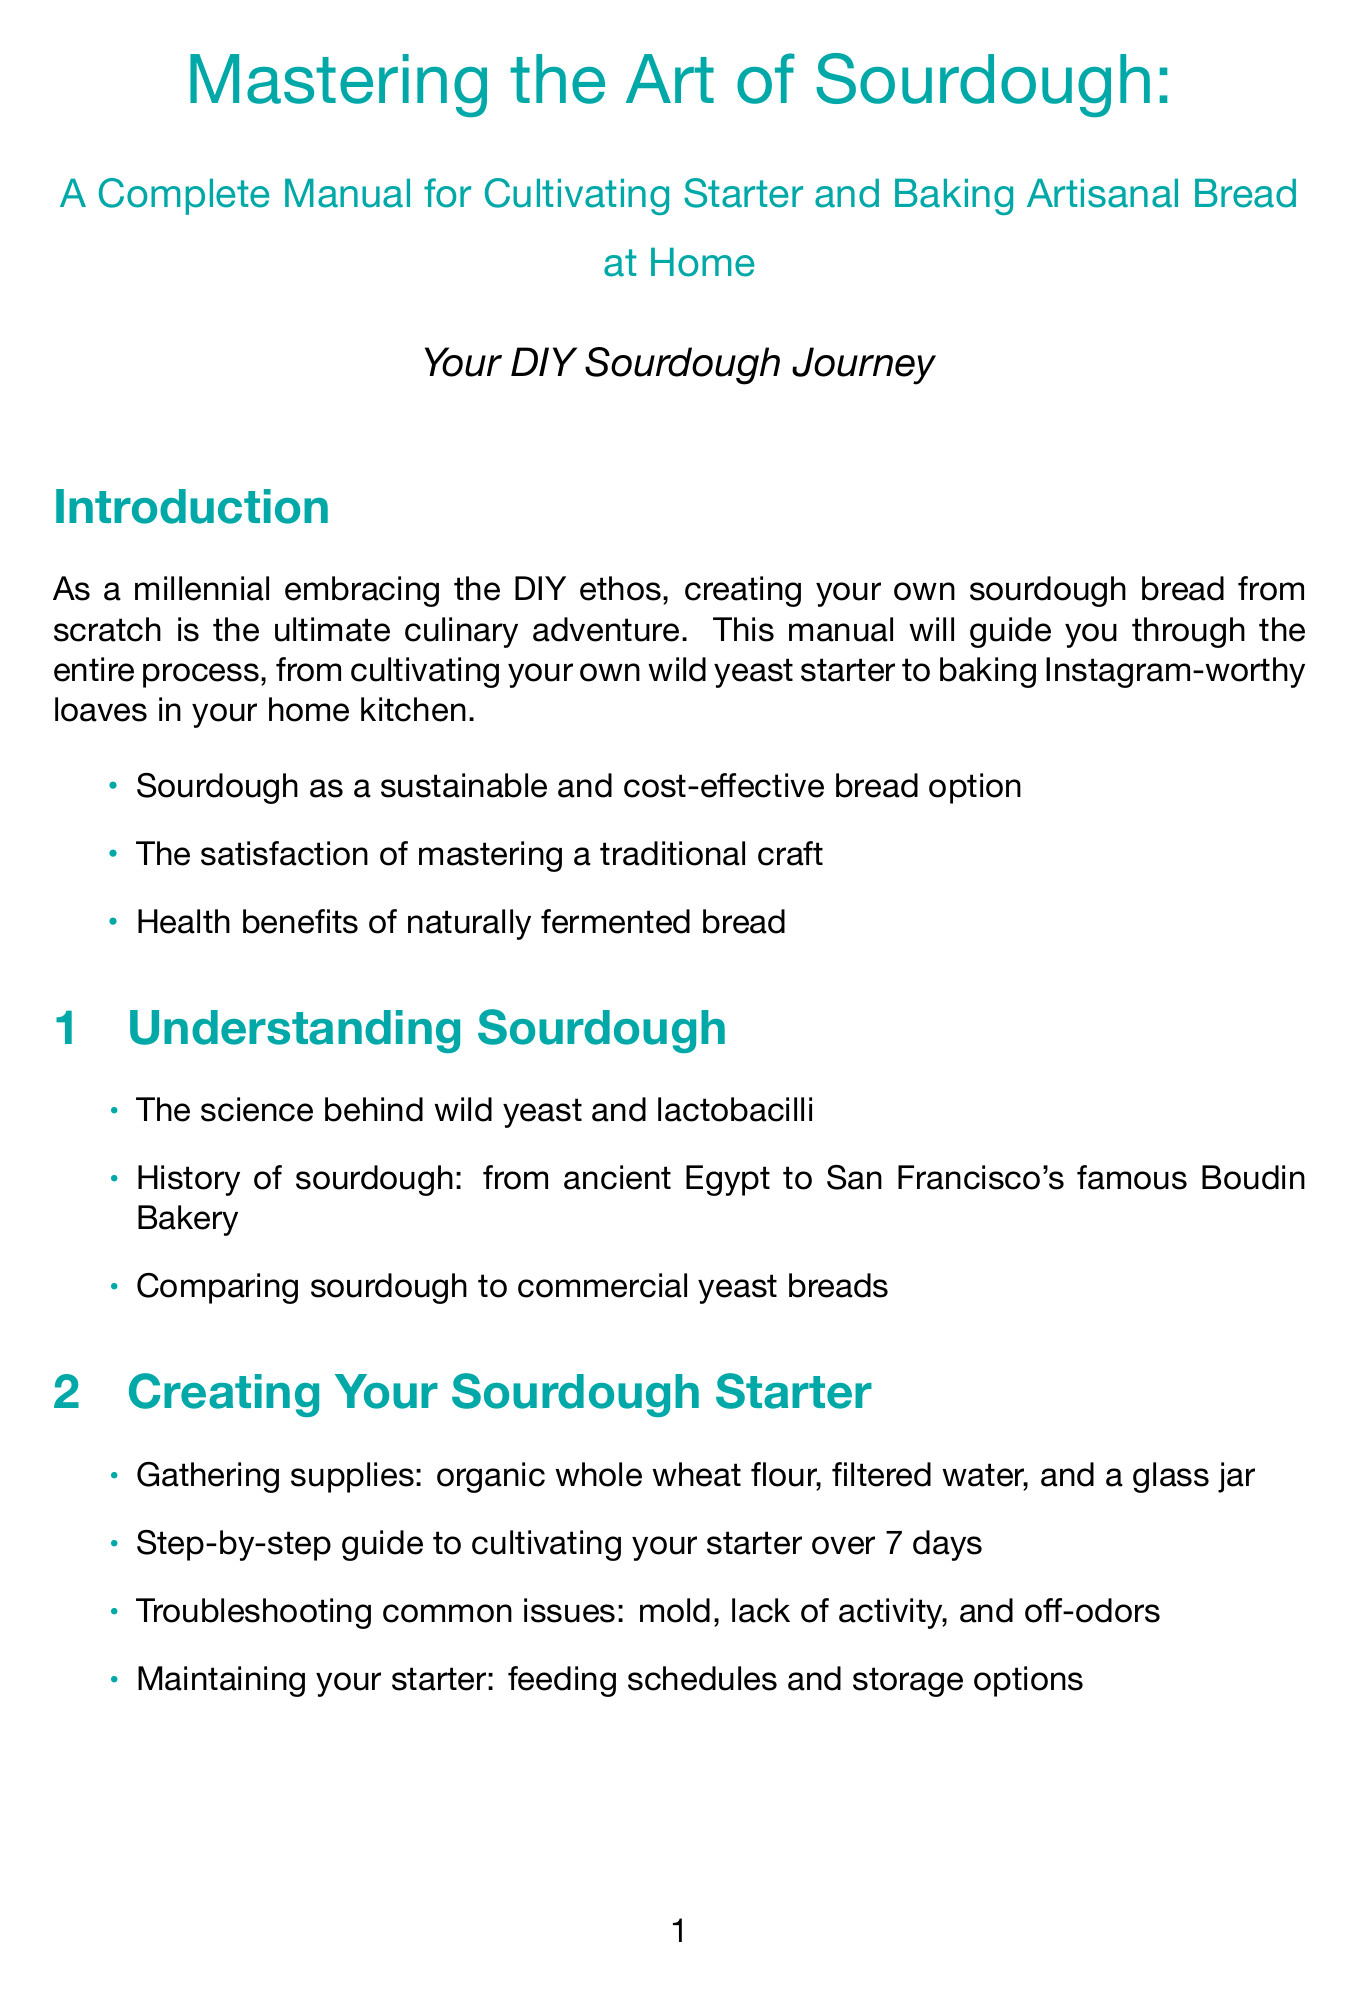What is the title of the manual? The title of the manual is stated at the beginning and is "Mastering the Art of Sourdough: A Complete Manual for Cultivating Starter and Baking Artisanal Bread at Home."
Answer: Mastering the Art of Sourdough: A Complete Manual for Cultivating Starter and Baking Artisanal Bread at Home How many days does it take to cultivate a sourdough starter? The time frame for cultivating a sourdough starter is mentioned in the section "Step-by-step guide to cultivating your starter over 7 days."
Answer: 7 days Name one optional tool mentioned for sourdough baking. The document lists optional tools, one of which is the Brod & Taylor proofing box.
Answer: Brod & Taylor proofing box What is emphasized as a benefit of naturally fermented bread? The manual mentions health benefits as a key point, highlighting its advantages.
Answer: Health benefits What does the "Stretch and fold technique" help with? The manual provides information that it is used for gluten development.
Answer: Gluten development What community activity is suggested for sourdough bakers? The document suggests organizing sourdough starter swaps in the community as an activity for bakers.
Answer: Sourdough starter swaps Which method is mentioned for achieving perfect crust development? The baking section highlights the Dutch oven method for perfect crust development.
Answer: Dutch oven method What is the first step in creating your sourdough starter? The manual specifies that gathering supplies is the first step in creating a sourdough starter.
Answer: Gathering supplies Name one historical aspect of sourdough discussed in the manual. The document discusses the history of sourdough, including its origins from ancient Egypt.
Answer: Ancient Egypt 